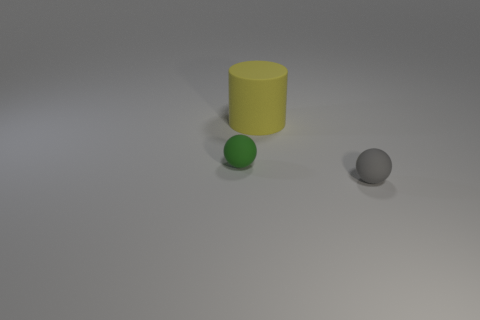Add 2 green balls. How many objects exist? 5 Subtract all cyan rubber blocks. Subtract all tiny green rubber objects. How many objects are left? 2 Add 1 cylinders. How many cylinders are left? 2 Add 2 tiny balls. How many tiny balls exist? 4 Subtract 0 gray cubes. How many objects are left? 3 Subtract all spheres. How many objects are left? 1 